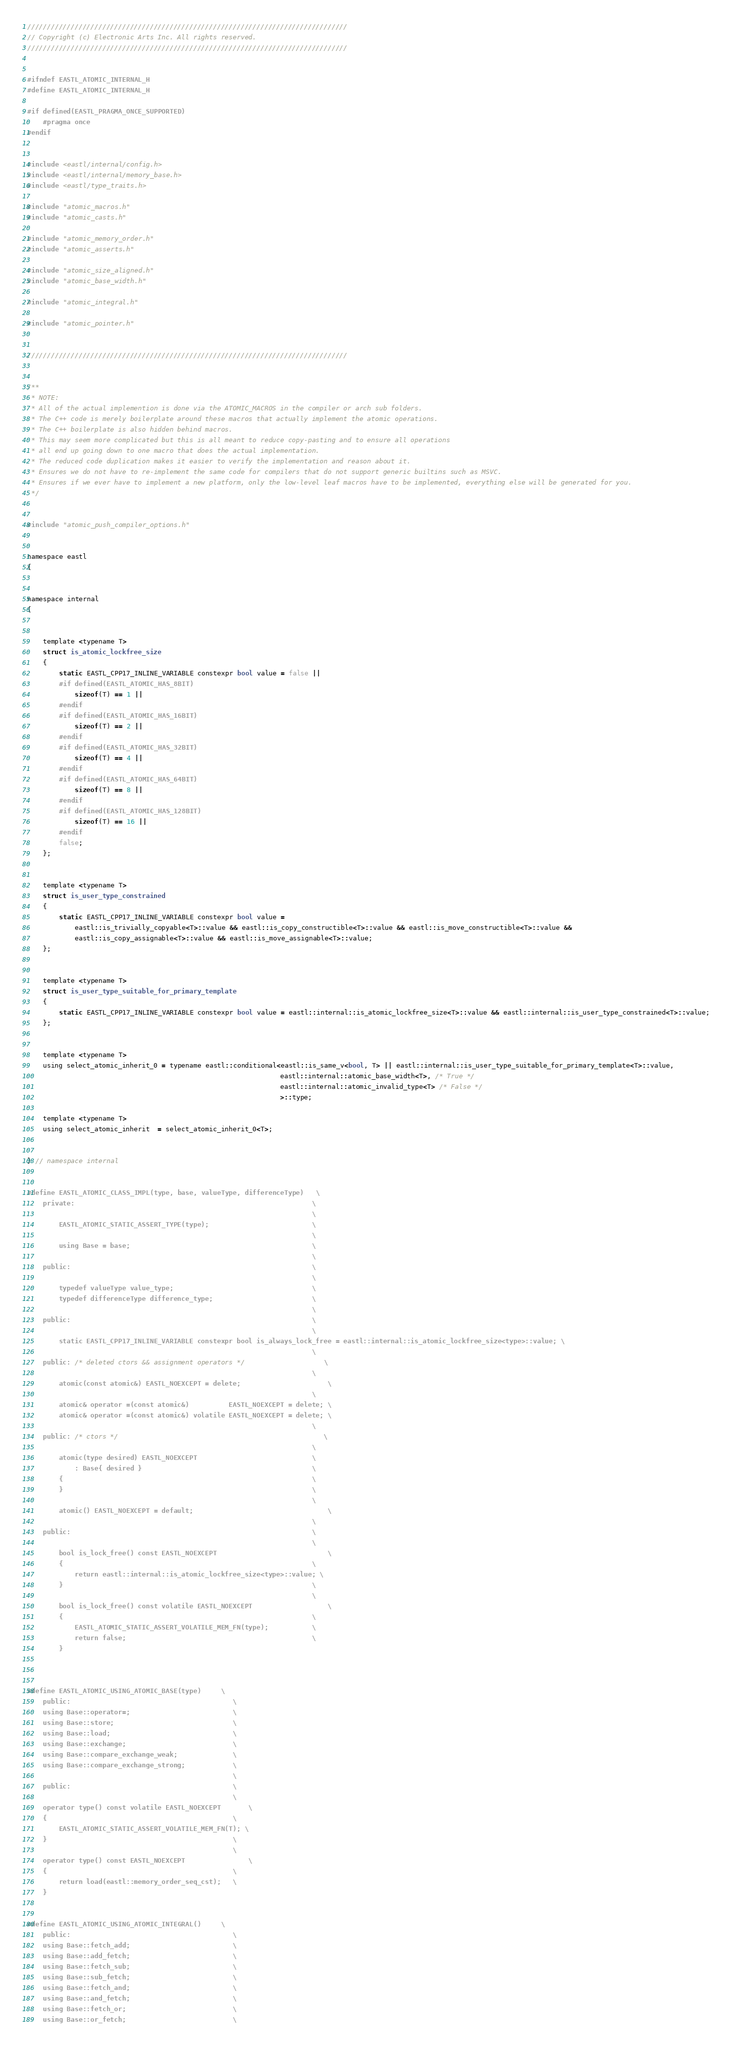<code> <loc_0><loc_0><loc_500><loc_500><_C_>/////////////////////////////////////////////////////////////////////////////////
// Copyright (c) Electronic Arts Inc. All rights reserved.
/////////////////////////////////////////////////////////////////////////////////


#ifndef EASTL_ATOMIC_INTERNAL_H
#define EASTL_ATOMIC_INTERNAL_H

#if defined(EASTL_PRAGMA_ONCE_SUPPORTED)
	#pragma once
#endif


#include <eastl/internal/config.h>
#include <eastl/internal/memory_base.h>
#include <eastl/type_traits.h>

#include "atomic_macros.h"
#include "atomic_casts.h"

#include "atomic_memory_order.h"
#include "atomic_asserts.h"

#include "atomic_size_aligned.h"
#include "atomic_base_width.h"

#include "atomic_integral.h"

#include "atomic_pointer.h"


/////////////////////////////////////////////////////////////////////////////////


/**
 * NOTE:
 * All of the actual implemention is done via the ATOMIC_MACROS in the compiler or arch sub folders.
 * The C++ code is merely boilerplate around these macros that actually implement the atomic operations.
 * The C++ boilerplate is also hidden behind macros.
 * This may seem more complicated but this is all meant to reduce copy-pasting and to ensure all operations
 * all end up going down to one macro that does the actual implementation.
 * The reduced code duplication makes it easier to verify the implementation and reason about it.
 * Ensures we do not have to re-implement the same code for compilers that do not support generic builtins such as MSVC.
 * Ensures if we ever have to implement a new platform, only the low-level leaf macros have to be implemented, everything else will be generated for you.
 */


#include "atomic_push_compiler_options.h"


namespace eastl
{


namespace internal
{


	template <typename T>
	struct is_atomic_lockfree_size
	{
		static EASTL_CPP17_INLINE_VARIABLE constexpr bool value = false ||
		#if defined(EASTL_ATOMIC_HAS_8BIT)
			sizeof(T) == 1 ||
		#endif
		#if defined(EASTL_ATOMIC_HAS_16BIT)
			sizeof(T) == 2 ||
		#endif
		#if defined(EASTL_ATOMIC_HAS_32BIT)
			sizeof(T) == 4 ||
		#endif
		#if defined(EASTL_ATOMIC_HAS_64BIT)
			sizeof(T) == 8 ||
		#endif
		#if defined(EASTL_ATOMIC_HAS_128BIT)
			sizeof(T) == 16 ||
		#endif
		false;
	};


	template <typename T>
	struct is_user_type_constrained
	{
		static EASTL_CPP17_INLINE_VARIABLE constexpr bool value =
			eastl::is_trivially_copyable<T>::value && eastl::is_copy_constructible<T>::value && eastl::is_move_constructible<T>::value &&
			eastl::is_copy_assignable<T>::value && eastl::is_move_assignable<T>::value;
	};


	template <typename T>
	struct is_user_type_suitable_for_primary_template
	{
		static EASTL_CPP17_INLINE_VARIABLE constexpr bool value = eastl::internal::is_atomic_lockfree_size<T>::value && eastl::internal::is_user_type_constrained<T>::value;
	};


	template <typename T>
	using select_atomic_inherit_0 = typename eastl::conditional<eastl::is_same_v<bool, T> || eastl::internal::is_user_type_suitable_for_primary_template<T>::value,
																eastl::internal::atomic_base_width<T>, /* True */
																eastl::internal::atomic_invalid_type<T> /* False */
																>::type;

	template <typename T>
	using select_atomic_inherit  = select_atomic_inherit_0<T>;


} // namespace internal


#define EASTL_ATOMIC_CLASS_IMPL(type, base, valueType, differenceType)	\
	private:															\
																		\
		EASTL_ATOMIC_STATIC_ASSERT_TYPE(type);							\
																		\
		using Base = base;												\
																		\
	public:																\
																		\
		typedef valueType value_type;									\
		typedef differenceType difference_type;							\
																		\
	public:																\
																		\
		static EASTL_CPP17_INLINE_VARIABLE constexpr bool is_always_lock_free = eastl::internal::is_atomic_lockfree_size<type>::value; \
																		\
	public: /* deleted ctors && assignment operators */					\
																		\
		atomic(const atomic&) EASTL_NOEXCEPT = delete;						\
																		\
		atomic& operator =(const atomic&)          EASTL_NOEXCEPT = delete; \
		atomic& operator =(const atomic&) volatile EASTL_NOEXCEPT = delete; \
																		\
	public: /* ctors */													\
																		\
		atomic(type desired) EASTL_NOEXCEPT								\
			: Base{ desired }											\
		{																\
		}																\
																		\
		atomic() EASTL_NOEXCEPT = default;									\
																		\
	public:																\
																		\
		bool is_lock_free() const EASTL_NOEXCEPT							\
		{																\
			return eastl::internal::is_atomic_lockfree_size<type>::value; \
		}																\
																		\
		bool is_lock_free() const volatile EASTL_NOEXCEPT					\
		{																\
			EASTL_ATOMIC_STATIC_ASSERT_VOLATILE_MEM_FN(type);			\
			return false;												\
		}



#define EASTL_ATOMIC_USING_ATOMIC_BASE(type)		\
	public:											\
	using Base::operator=;							\
	using Base::store;								\
	using Base::load;								\
	using Base::exchange;							\
	using Base::compare_exchange_weak;				\
	using Base::compare_exchange_strong;			\
													\
	public:											\
													\
	operator type() const volatile EASTL_NOEXCEPT		\
	{												\
		EASTL_ATOMIC_STATIC_ASSERT_VOLATILE_MEM_FN(T); \
	}												\
													\
	operator type() const EASTL_NOEXCEPT				\
	{												\
		return load(eastl::memory_order_seq_cst);	\
	}


#define EASTL_ATOMIC_USING_ATOMIC_INTEGRAL()		\
	public:											\
	using Base::fetch_add;							\
	using Base::add_fetch;							\
	using Base::fetch_sub;							\
	using Base::sub_fetch;							\
	using Base::fetch_and;							\
	using Base::and_fetch;							\
	using Base::fetch_or;							\
	using Base::or_fetch;							\</code> 